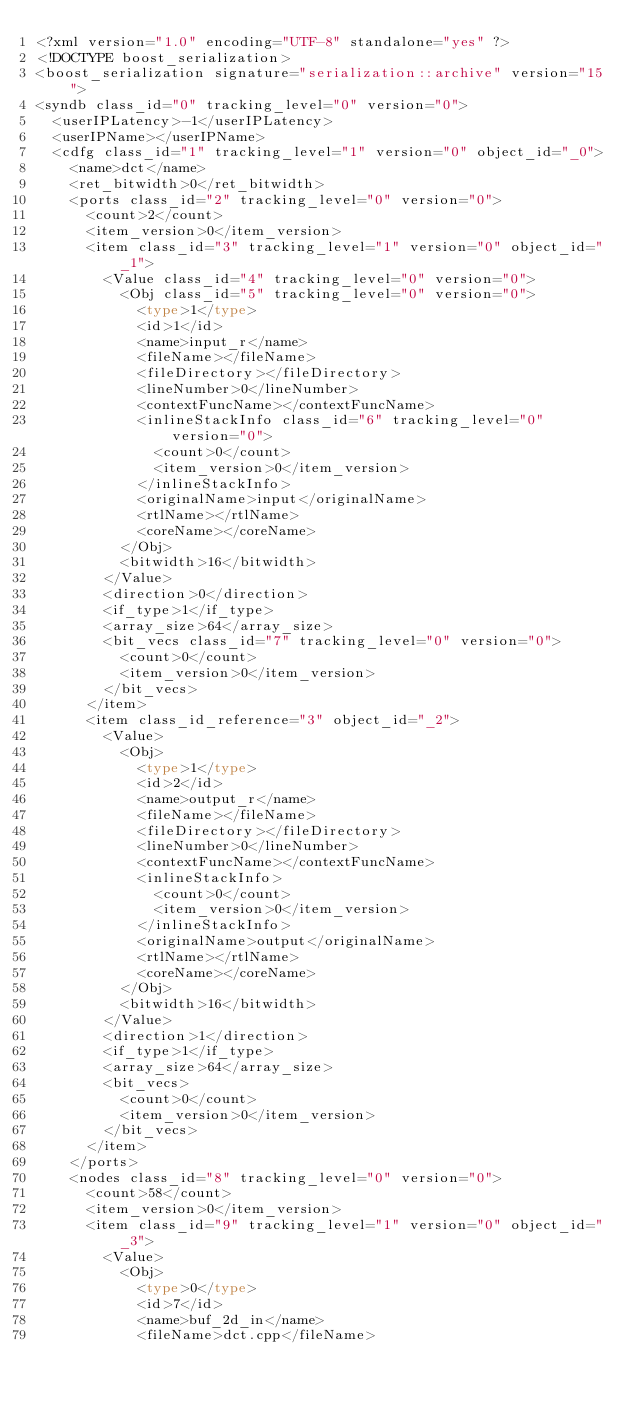<code> <loc_0><loc_0><loc_500><loc_500><_Ada_><?xml version="1.0" encoding="UTF-8" standalone="yes" ?>
<!DOCTYPE boost_serialization>
<boost_serialization signature="serialization::archive" version="15">
<syndb class_id="0" tracking_level="0" version="0">
	<userIPLatency>-1</userIPLatency>
	<userIPName></userIPName>
	<cdfg class_id="1" tracking_level="1" version="0" object_id="_0">
		<name>dct</name>
		<ret_bitwidth>0</ret_bitwidth>
		<ports class_id="2" tracking_level="0" version="0">
			<count>2</count>
			<item_version>0</item_version>
			<item class_id="3" tracking_level="1" version="0" object_id="_1">
				<Value class_id="4" tracking_level="0" version="0">
					<Obj class_id="5" tracking_level="0" version="0">
						<type>1</type>
						<id>1</id>
						<name>input_r</name>
						<fileName></fileName>
						<fileDirectory></fileDirectory>
						<lineNumber>0</lineNumber>
						<contextFuncName></contextFuncName>
						<inlineStackInfo class_id="6" tracking_level="0" version="0">
							<count>0</count>
							<item_version>0</item_version>
						</inlineStackInfo>
						<originalName>input</originalName>
						<rtlName></rtlName>
						<coreName></coreName>
					</Obj>
					<bitwidth>16</bitwidth>
				</Value>
				<direction>0</direction>
				<if_type>1</if_type>
				<array_size>64</array_size>
				<bit_vecs class_id="7" tracking_level="0" version="0">
					<count>0</count>
					<item_version>0</item_version>
				</bit_vecs>
			</item>
			<item class_id_reference="3" object_id="_2">
				<Value>
					<Obj>
						<type>1</type>
						<id>2</id>
						<name>output_r</name>
						<fileName></fileName>
						<fileDirectory></fileDirectory>
						<lineNumber>0</lineNumber>
						<contextFuncName></contextFuncName>
						<inlineStackInfo>
							<count>0</count>
							<item_version>0</item_version>
						</inlineStackInfo>
						<originalName>output</originalName>
						<rtlName></rtlName>
						<coreName></coreName>
					</Obj>
					<bitwidth>16</bitwidth>
				</Value>
				<direction>1</direction>
				<if_type>1</if_type>
				<array_size>64</array_size>
				<bit_vecs>
					<count>0</count>
					<item_version>0</item_version>
				</bit_vecs>
			</item>
		</ports>
		<nodes class_id="8" tracking_level="0" version="0">
			<count>58</count>
			<item_version>0</item_version>
			<item class_id="9" tracking_level="1" version="0" object_id="_3">
				<Value>
					<Obj>
						<type>0</type>
						<id>7</id>
						<name>buf_2d_in</name>
						<fileName>dct.cpp</fileName></code> 